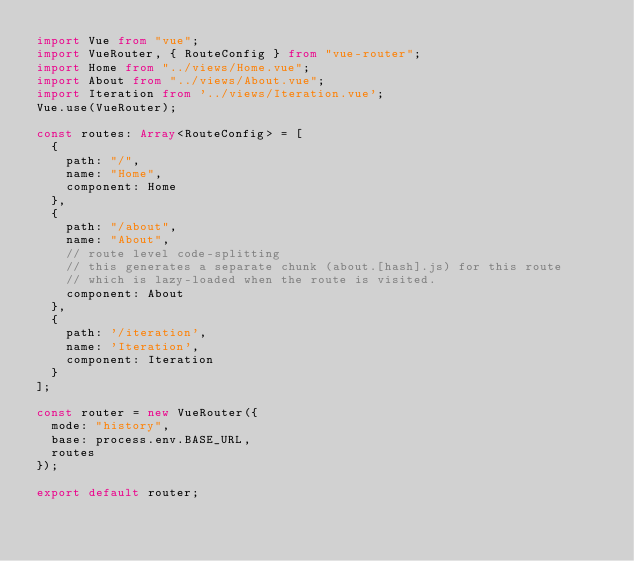<code> <loc_0><loc_0><loc_500><loc_500><_TypeScript_>import Vue from "vue";
import VueRouter, { RouteConfig } from "vue-router";
import Home from "../views/Home.vue";
import About from "../views/About.vue";
import Iteration from '../views/Iteration.vue';
Vue.use(VueRouter);

const routes: Array<RouteConfig> = [
  {
    path: "/",
    name: "Home",
    component: Home
  },
  {
    path: "/about",
    name: "About",
    // route level code-splitting
    // this generates a separate chunk (about.[hash].js) for this route
    // which is lazy-loaded when the route is visited.
    component: About
  },
  {
    path: '/iteration',
    name: 'Iteration',
    component: Iteration
  }
];

const router = new VueRouter({
  mode: "history",
  base: process.env.BASE_URL,
  routes
});

export default router;
</code> 